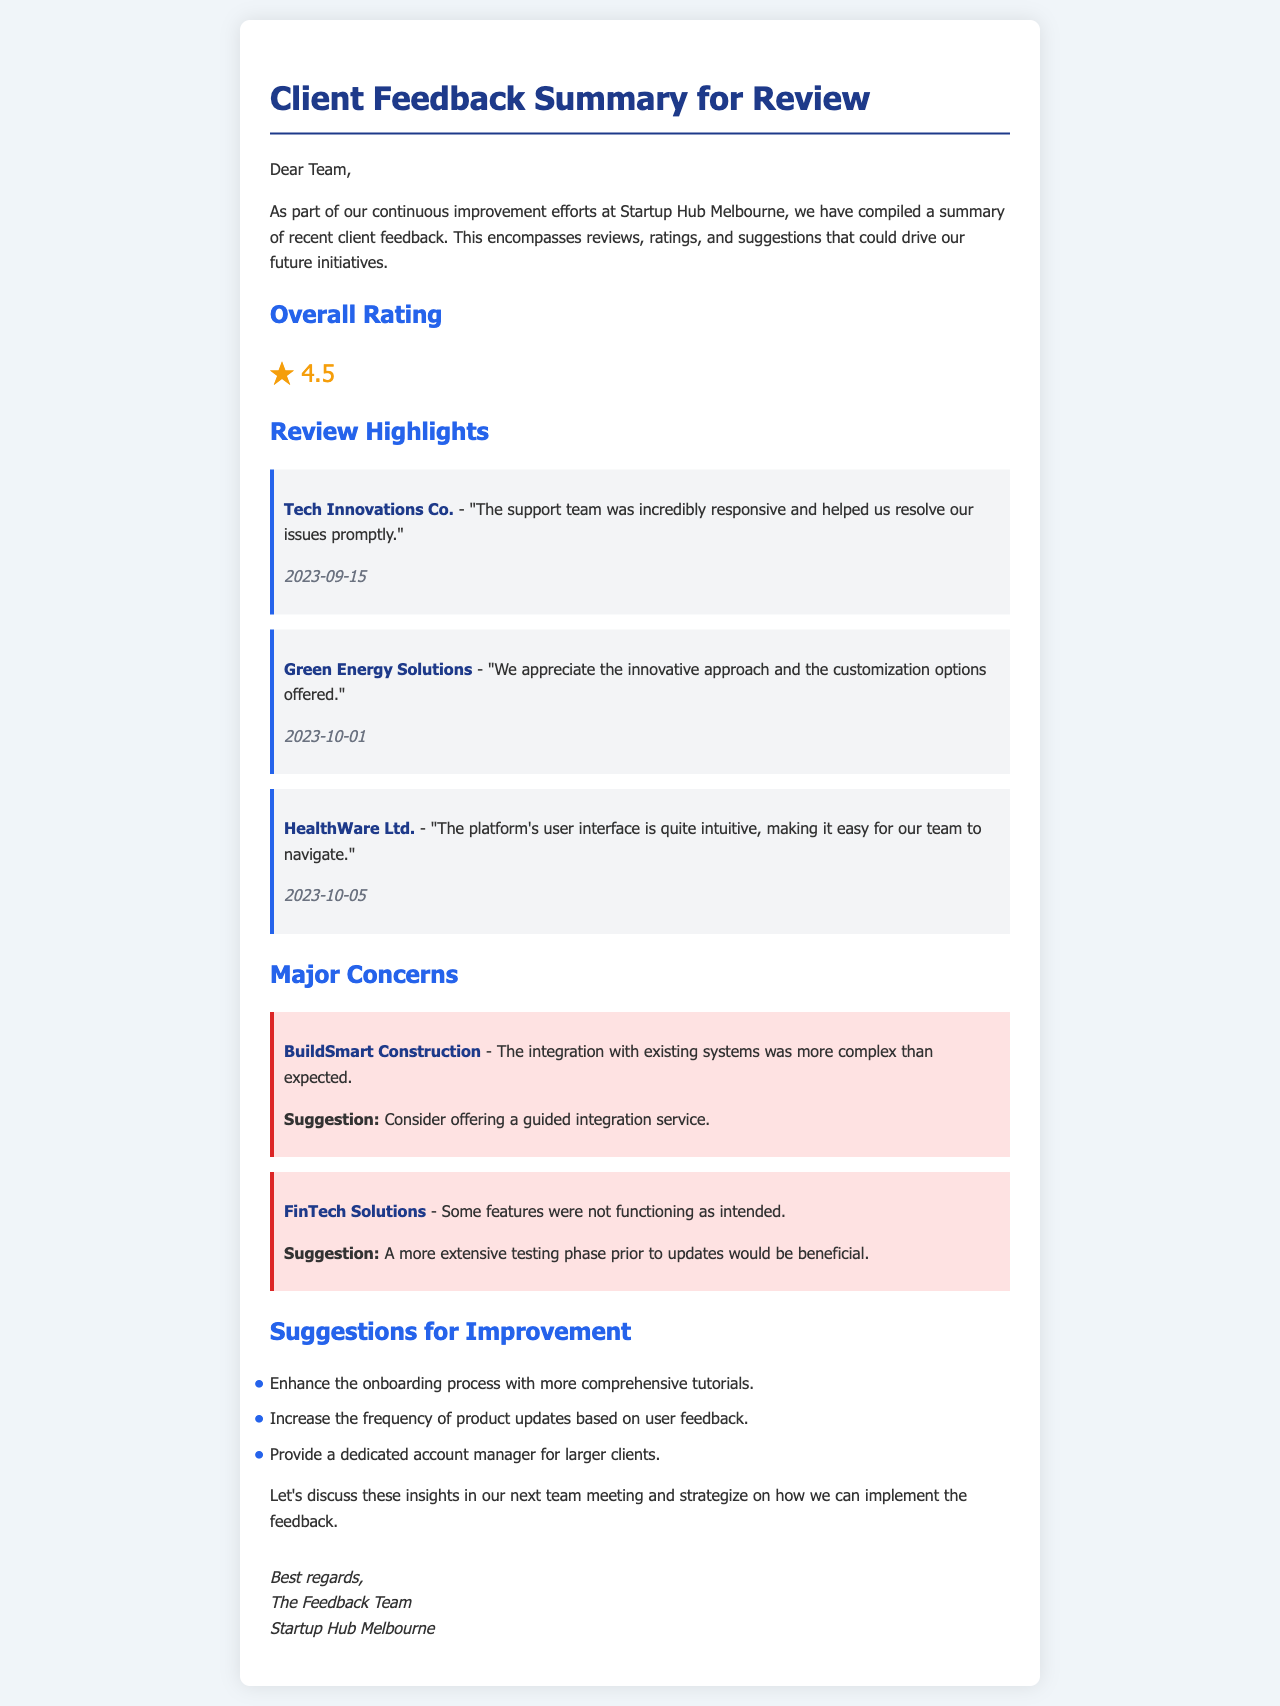What is the overall rating? The overall rating is provided in the document and indicates the average satisfaction level of the clients.
Answer: 4.5 Who is the client that mentioned responsive support? The document cites a specific client who appreciated the responsiveness of the support team.
Answer: Tech Innovations Co When did HealthWare Ltd. provide their feedback? The date on which HealthWare Ltd. gave their review is stated in the document.
Answer: 2023-10-05 What major concern does BuildSmart Construction have? A specific concern from BuildSmart Construction is highlighted in the document regarding their experience.
Answer: Integration complexity What is one suggestion for improvement mentioned in the document? The document lists several suggestions for improving client services, reflecting what clients would like to see enhanced.
Answer: Enhance the onboarding process with more comprehensive tutorials 